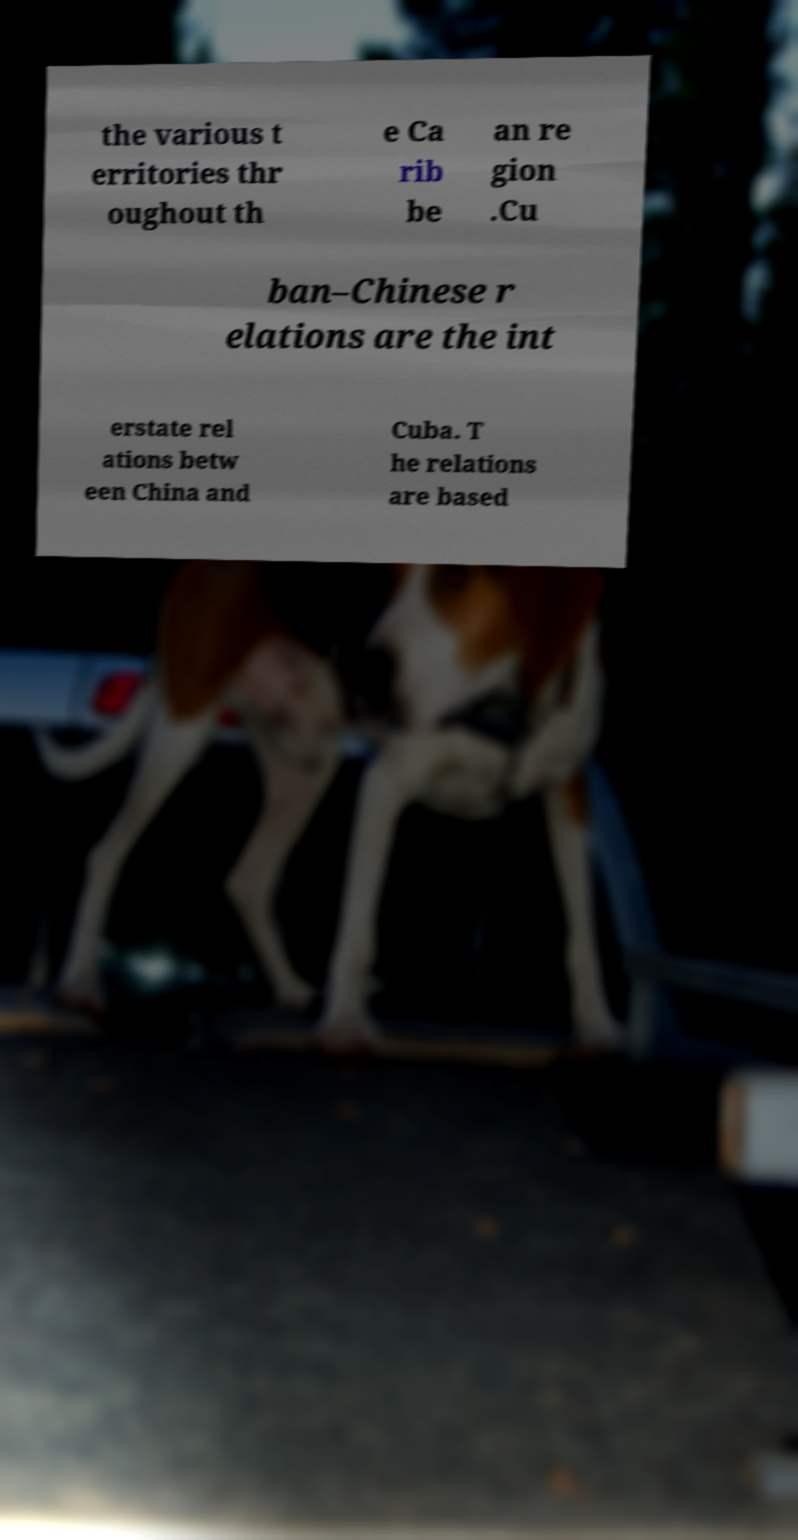Can you read and provide the text displayed in the image?This photo seems to have some interesting text. Can you extract and type it out for me? the various t erritories thr oughout th e Ca rib be an re gion .Cu ban–Chinese r elations are the int erstate rel ations betw een China and Cuba. T he relations are based 